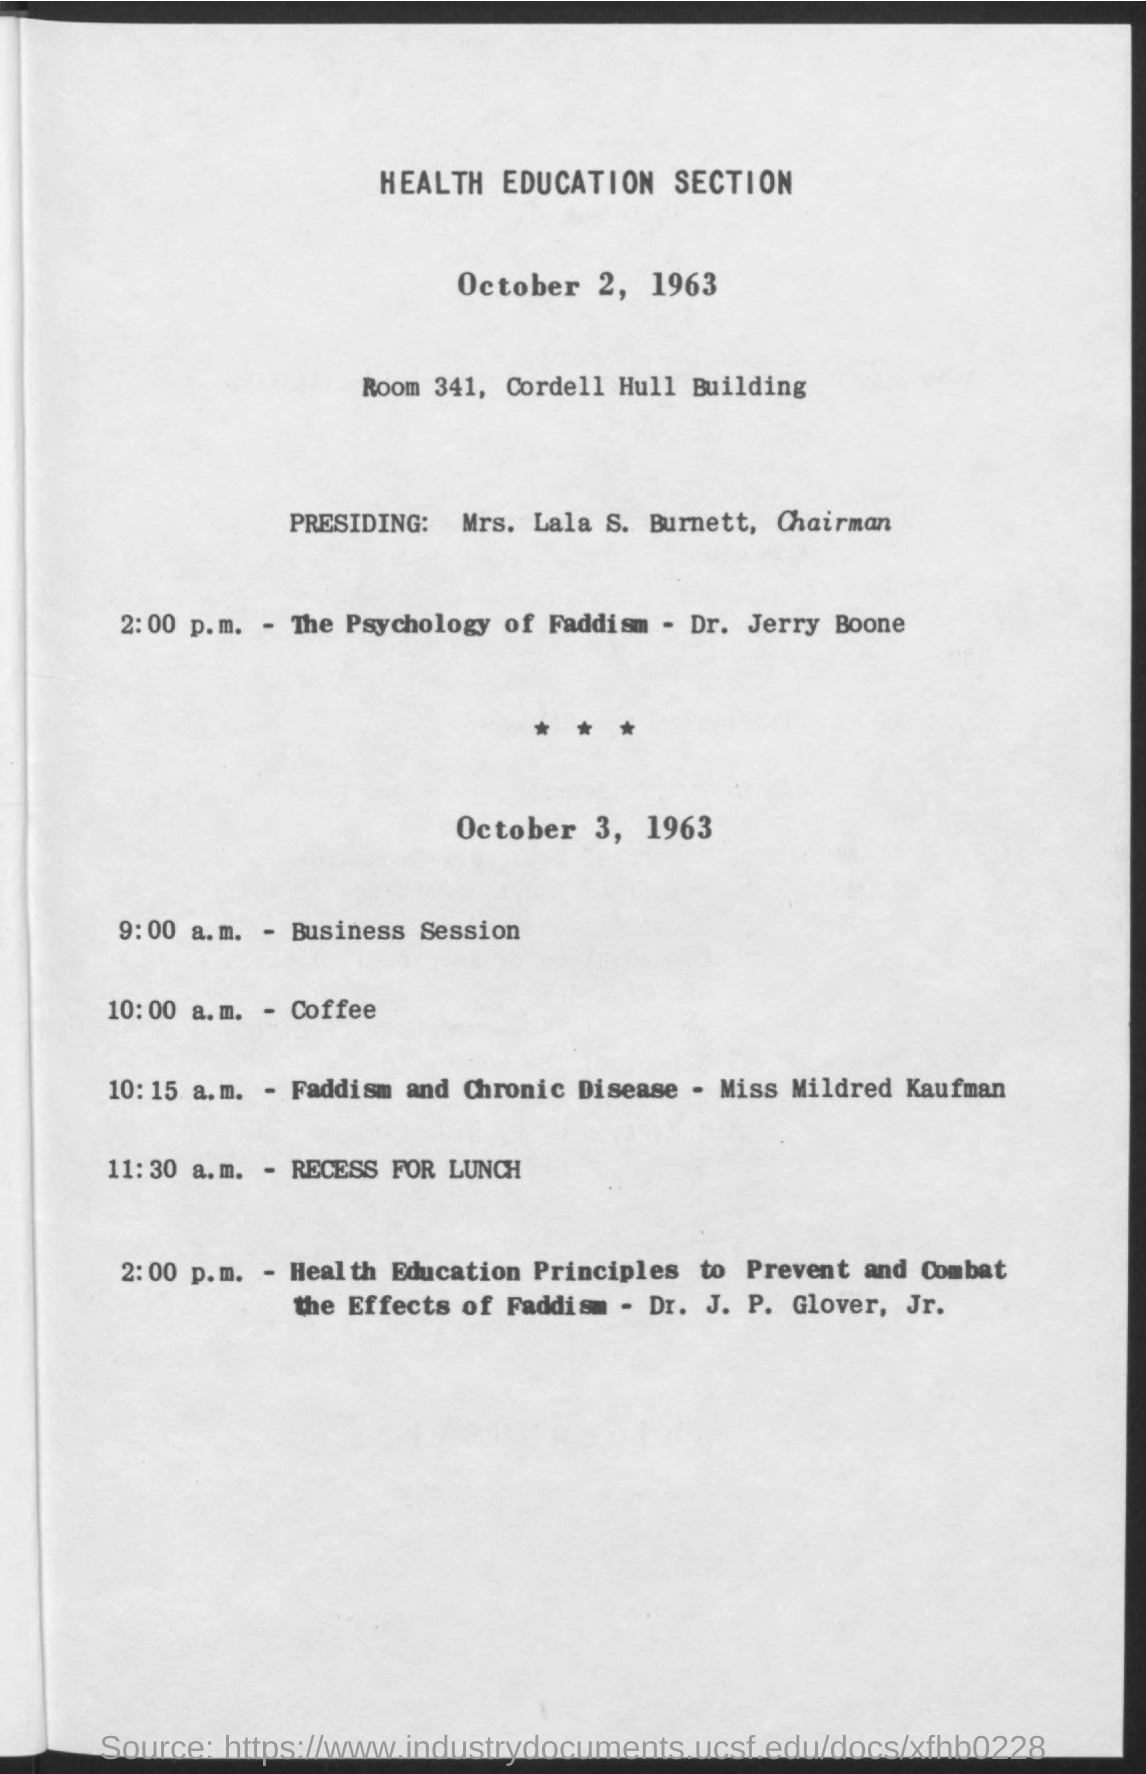Where is it held at?
Your answer should be compact. ROOM 341, CORDELL HULL BUILDING. Who is it presided by?
Ensure brevity in your answer.  MRS. LALA S. BURNETT. What time is coffee?
Provide a short and direct response. 10:00 a.M. 